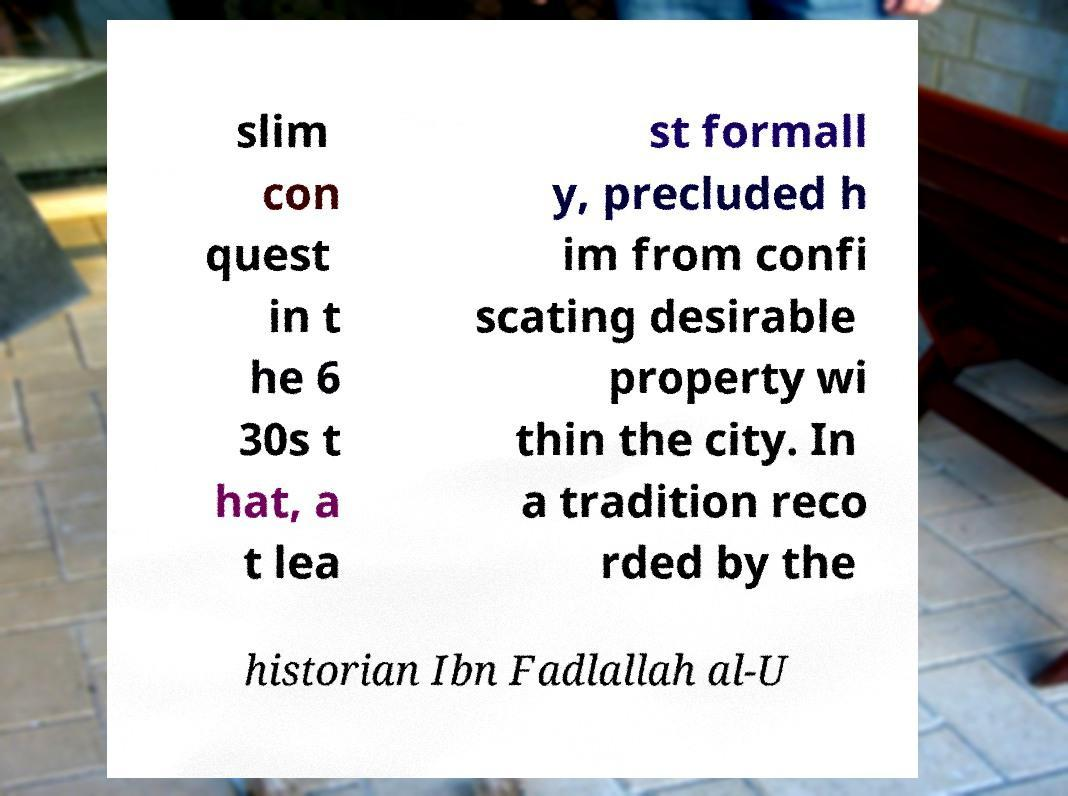Can you accurately transcribe the text from the provided image for me? slim con quest in t he 6 30s t hat, a t lea st formall y, precluded h im from confi scating desirable property wi thin the city. In a tradition reco rded by the historian Ibn Fadlallah al-U 